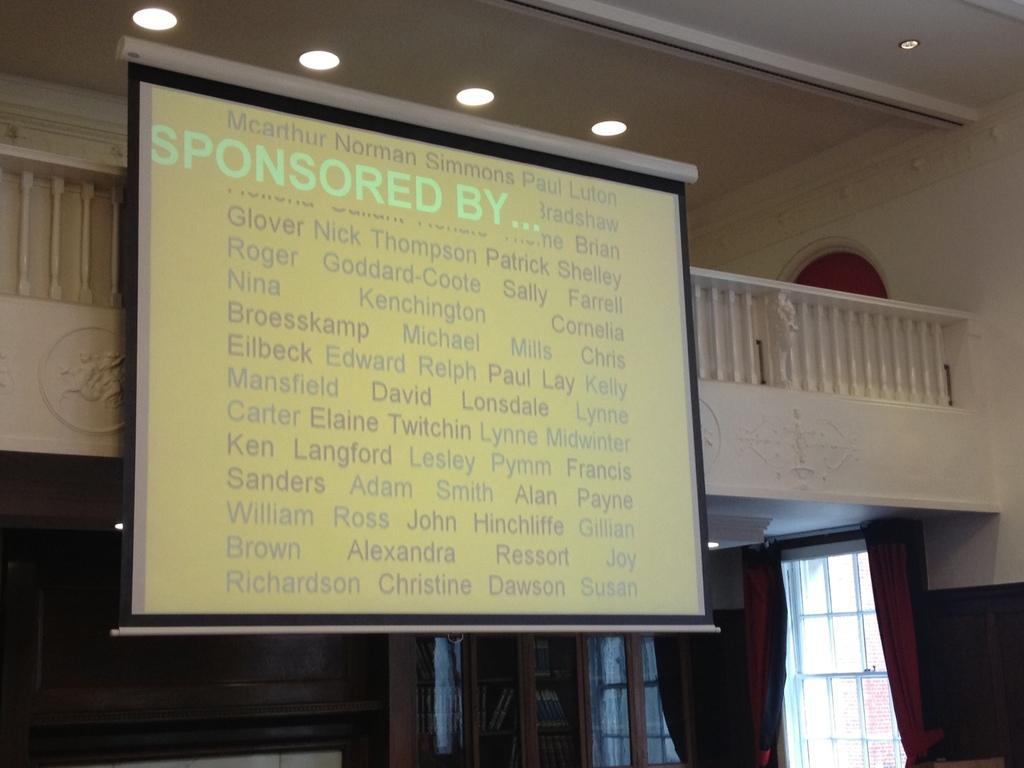In one or two sentences, can you explain what this image depicts? In this picture I can see there is a screen and there is something displayed on the screen and there is a wall in the backdrop and lights attached to the ceiling, there are windows with curtains. 